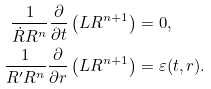<formula> <loc_0><loc_0><loc_500><loc_500>\frac { 1 } { \dot { R } R ^ { n } } \frac { \partial } { \partial t } \left ( L R ^ { n + 1 } \right ) & = 0 , \\ \frac { 1 } { R ^ { \prime } R ^ { n } } \frac { \partial } { \partial r } \left ( L R ^ { n + 1 } \right ) & = \varepsilon ( t , r ) .</formula> 